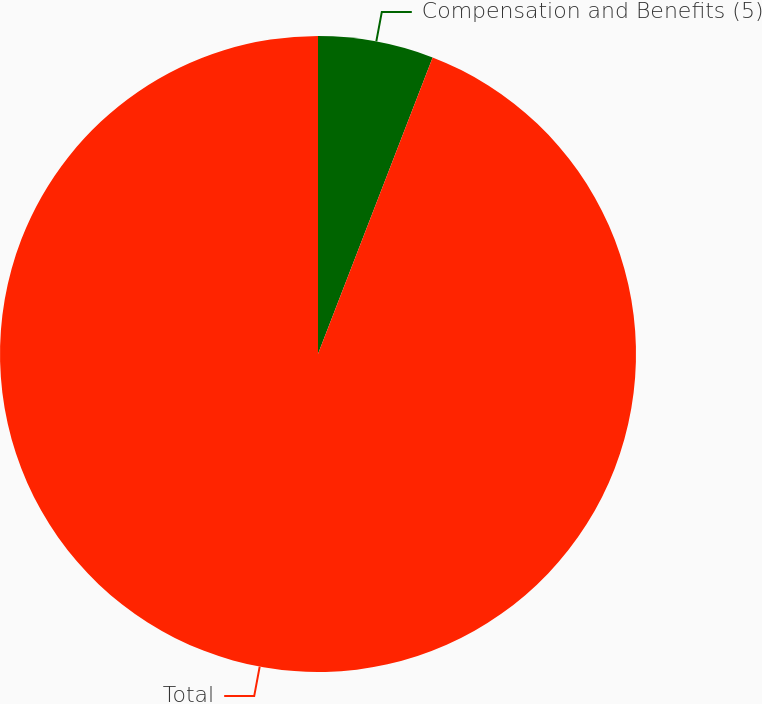<chart> <loc_0><loc_0><loc_500><loc_500><pie_chart><fcel>Compensation and Benefits (5)<fcel>Total<nl><fcel>5.87%<fcel>94.13%<nl></chart> 